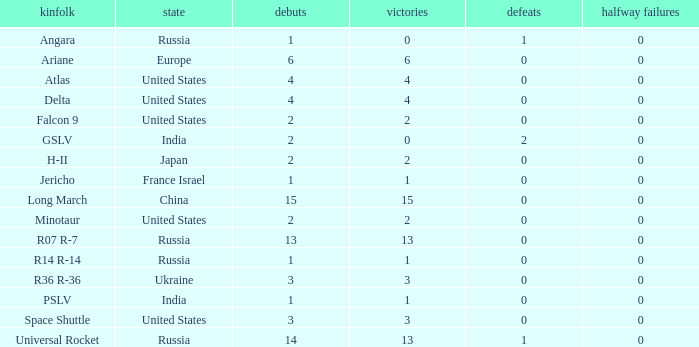What is the number of failure for the country of Russia, and a Family of r14 r-14, and a Partial failures smaller than 0? 0.0. 